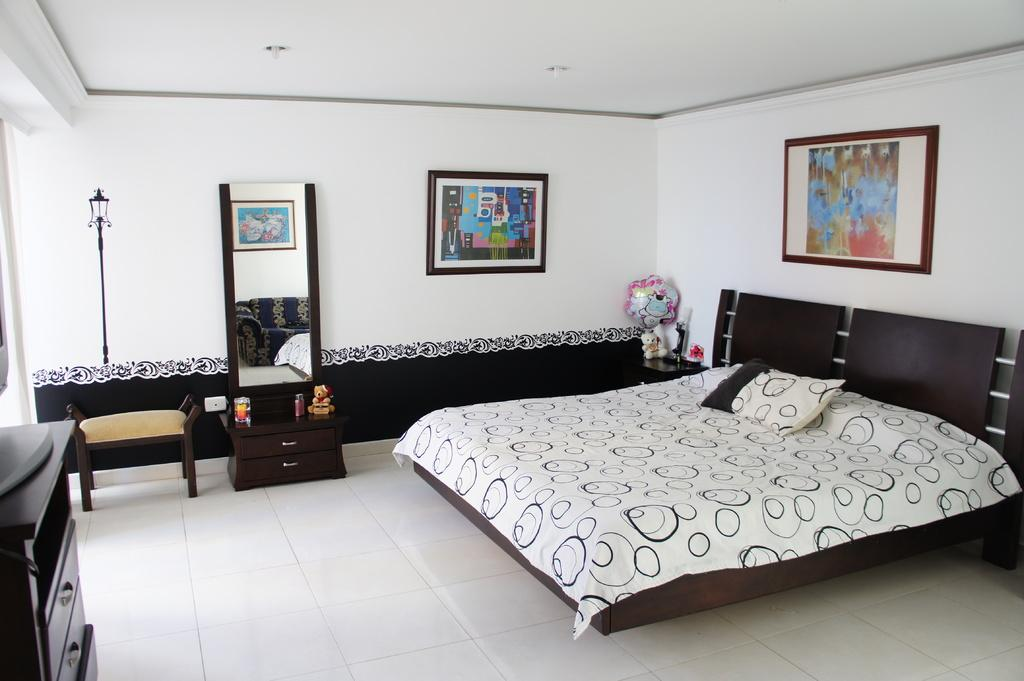What type of furniture is present in the image? There is a bed, drawers, and a dressing table in the image. What is on top of the dressing table? There is a mirror on the dressing table. Are there any decorative items on the wall? Yes, there are photo frames on the wall. What type of mist can be seen surrounding the bed in the image? There is no mist present in the image; it features of the room, such as the bed, drawers, and dressing table, are clearly visible. 